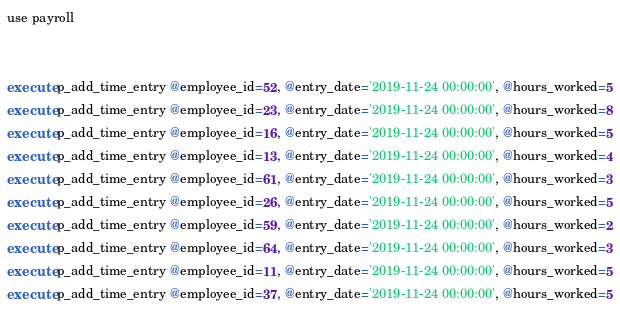<code> <loc_0><loc_0><loc_500><loc_500><_SQL_>use payroll


execute p_add_time_entry @employee_id=52, @entry_date='2019-11-24 00:00:00', @hours_worked=5
execute p_add_time_entry @employee_id=23, @entry_date='2019-11-24 00:00:00', @hours_worked=8
execute p_add_time_entry @employee_id=16, @entry_date='2019-11-24 00:00:00', @hours_worked=5
execute p_add_time_entry @employee_id=13, @entry_date='2019-11-24 00:00:00', @hours_worked=4
execute p_add_time_entry @employee_id=61, @entry_date='2019-11-24 00:00:00', @hours_worked=3
execute p_add_time_entry @employee_id=26, @entry_date='2019-11-24 00:00:00', @hours_worked=5
execute p_add_time_entry @employee_id=59, @entry_date='2019-11-24 00:00:00', @hours_worked=2
execute p_add_time_entry @employee_id=64, @entry_date='2019-11-24 00:00:00', @hours_worked=3
execute p_add_time_entry @employee_id=11, @entry_date='2019-11-24 00:00:00', @hours_worked=5
execute p_add_time_entry @employee_id=37, @entry_date='2019-11-24 00:00:00', @hours_worked=5</code> 